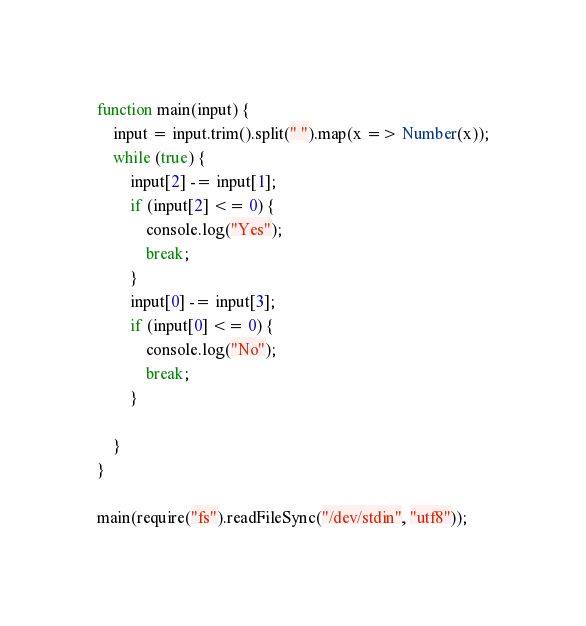Convert code to text. <code><loc_0><loc_0><loc_500><loc_500><_JavaScript_>function main(input) {
    input = input.trim().split(" ").map(x => Number(x));
    while (true) {
        input[2] -= input[1];
        if (input[2] <= 0) {
            console.log("Yes");
            break;
        }
        input[0] -= input[3];
        if (input[0] <= 0) {
            console.log("No");
            break;
        }
        
    }
}

main(require("fs").readFileSync("/dev/stdin", "utf8"));</code> 